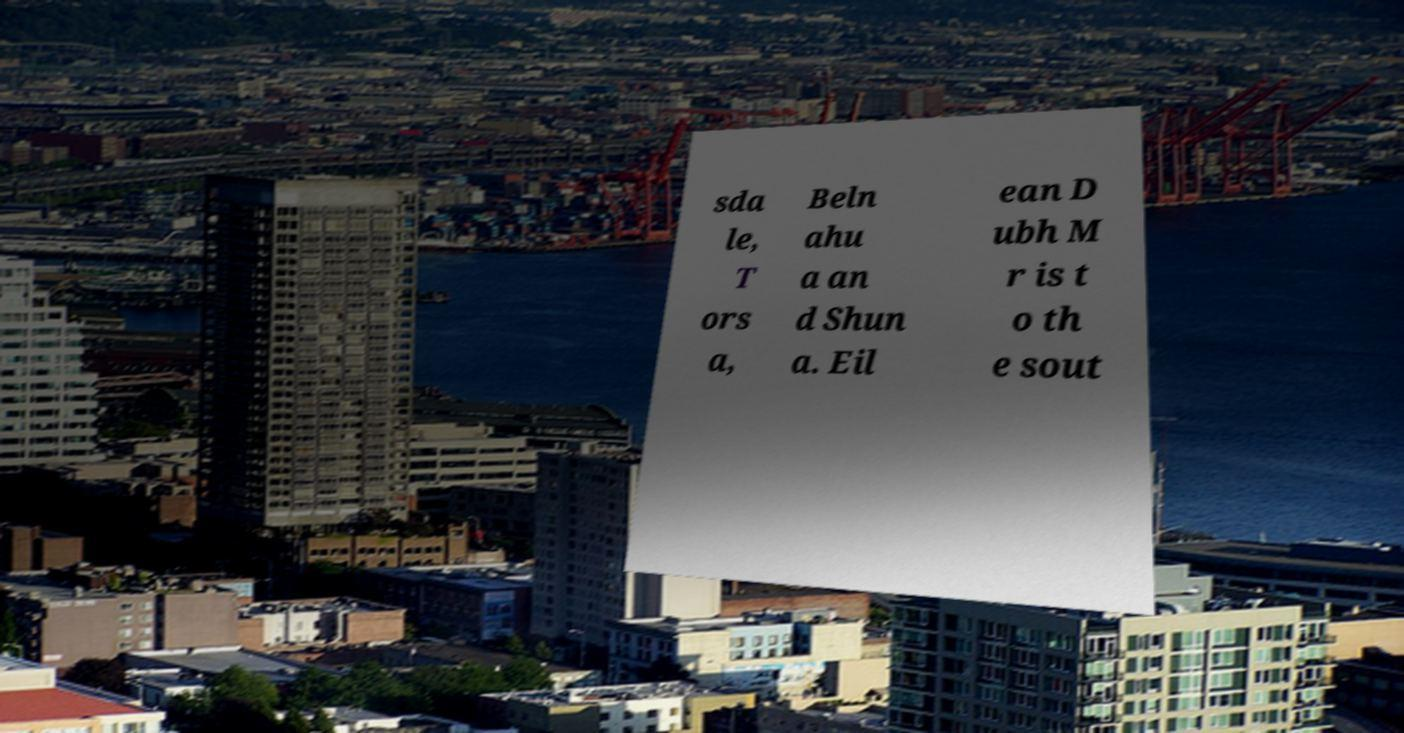Can you read and provide the text displayed in the image?This photo seems to have some interesting text. Can you extract and type it out for me? sda le, T ors a, Beln ahu a an d Shun a. Eil ean D ubh M r is t o th e sout 